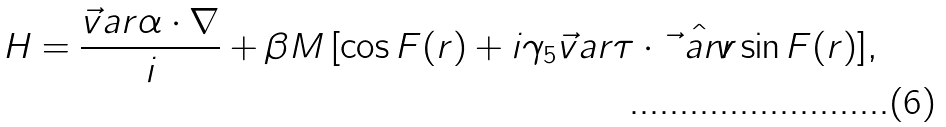<formula> <loc_0><loc_0><loc_500><loc_500>H = \frac { \vec { v } a r { \alpha } \cdot \nabla } { i } + \beta M \, [ \cos F ( r ) + i \gamma _ { 5 } \vec { v } a r { \tau } \cdot \hat { \vec { v } a r { r } } \sin F ( r ) ] ,</formula> 